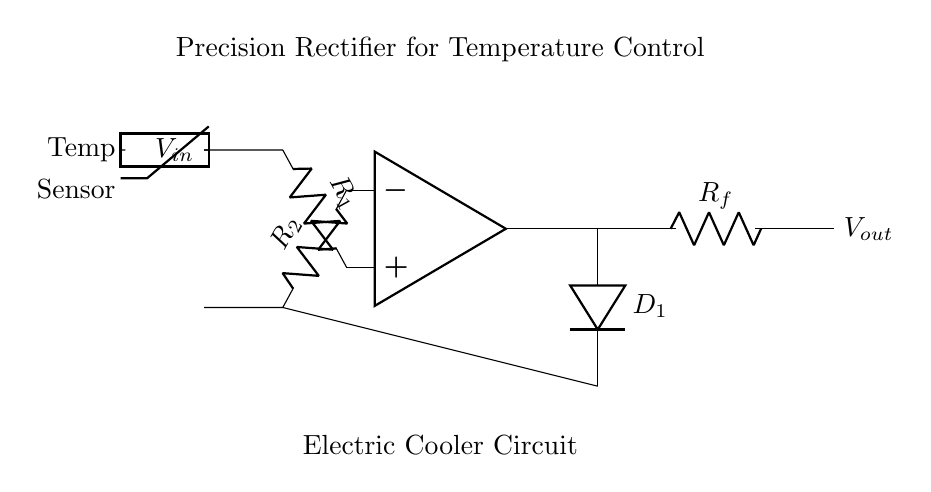What is the main function of this circuit? The main function of the circuit is to provide precision rectification for accurate temperature control in an electric cooler. This is achieved by converting the alternating input signal into a controlled direct output, which is crucial for maintaining the desired temperature for beverages.
Answer: Precision rectification What type of sensor is used in this circuit? The circuit uses a thermistor, which is a type of temperature sensor that changes resistance with temperature variations. This allows the circuit to sense the temperature accurately for control purposes.
Answer: Thermistor What does the diode in the circuit do? The diode serves to allow current to pass in one direction only, which is essential in precision rectifiers to eliminate negative voltages, ensuring that the output reflects only positive values corresponding to the input signal's temperature variations.
Answer: Allow current in one direction What is the role of the operational amplifier in this circuit? The operational amplifier amplifies the difference between the input voltages across the resistors, which is essential for processing the temperature-related signal accurately and providing a precise output voltage necessary for temperature control.
Answer: Amplify the input voltages How many resistors are present in this circuit? There are three resistors in the circuit: R1, R2, and the feedback resistor Rf. Each one plays a role in setting the gain and the feedback mechanism, which contribute to the precision of the rectifier.
Answer: Three resistors What would happen if the thermistor were removed from the circuit? If the thermistor were removed, the circuit would lack temperature sensing capability. As a result, the precision rectifier would not be able to adjust the output based on temperature changes, leading to inefficient temperature control in the cooler.
Answer: No temperature control 